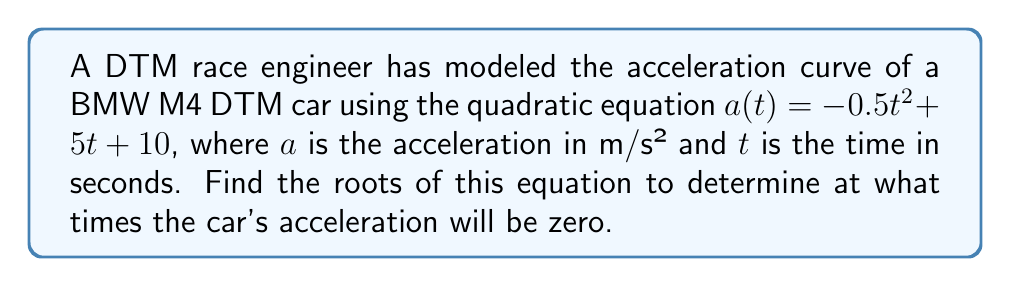Can you answer this question? To find the roots of the quadratic equation, we need to solve $a(t) = 0$:

$$-0.5t^2 + 5t + 10 = 0$$

We can use the quadratic formula: $t = \frac{-b \pm \sqrt{b^2 - 4ac}}{2a}$

Where $a = -0.5$, $b = 5$, and $c = 10$

Substituting these values:

$$t = \frac{-5 \pm \sqrt{5^2 - 4(-0.5)(10)}}{2(-0.5)}$$

$$t = \frac{-5 \pm \sqrt{25 + 20}}{-1}$$

$$t = \frac{-5 \pm \sqrt{45}}{-1}$$

$$t = \frac{-5 \pm 6.708203932499369}{-1}$$

This gives us two solutions:

$$t_1 = \frac{-5 + 6.708203932499369}{-1} = -1.708203932499369$$

$$t_2 = \frac{-5 - 6.708203932499369}{-1} = 11.708203932499369$$

Since time cannot be negative in this context, we discard the negative solution.
Answer: The acceleration of the BMW M4 DTM car will be zero at approximately $t = 11.71$ seconds. 